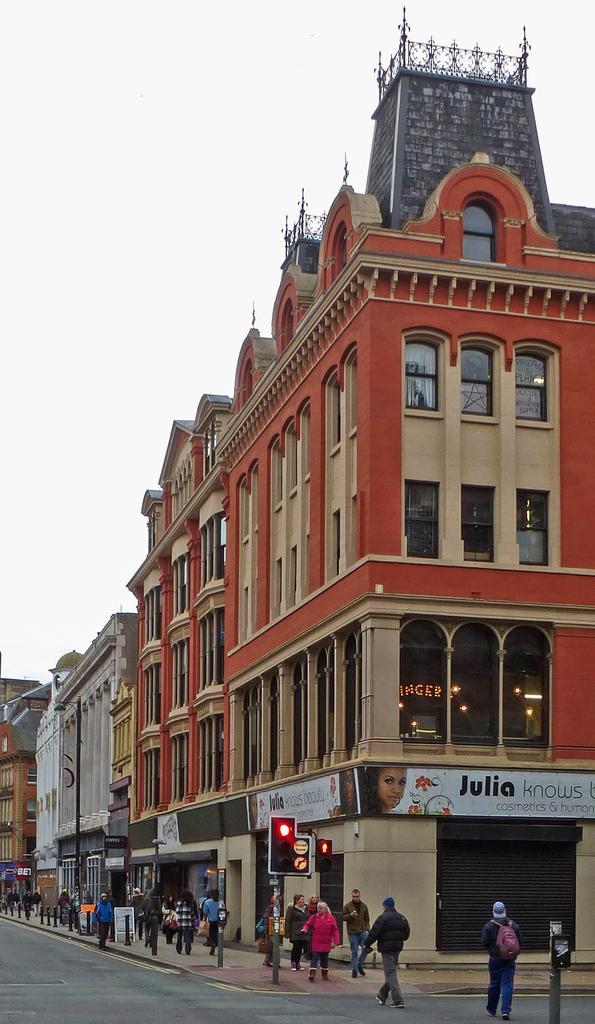Describe this image in one or two sentences. The picture is clicked outside a city. In the foreground of the picture there are people, poles, signal, sign board and road. In the center of the picture there are buildings. Sky is cloudy. 